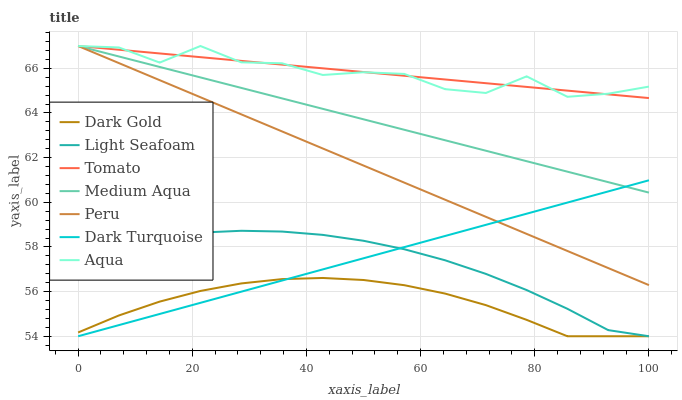Does Dark Gold have the minimum area under the curve?
Answer yes or no. Yes. Does Tomato have the maximum area under the curve?
Answer yes or no. Yes. Does Dark Turquoise have the minimum area under the curve?
Answer yes or no. No. Does Dark Turquoise have the maximum area under the curve?
Answer yes or no. No. Is Dark Turquoise the smoothest?
Answer yes or no. Yes. Is Aqua the roughest?
Answer yes or no. Yes. Is Dark Gold the smoothest?
Answer yes or no. No. Is Dark Gold the roughest?
Answer yes or no. No. Does Dark Gold have the lowest value?
Answer yes or no. Yes. Does Aqua have the lowest value?
Answer yes or no. No. Does Peru have the highest value?
Answer yes or no. Yes. Does Dark Turquoise have the highest value?
Answer yes or no. No. Is Dark Gold less than Tomato?
Answer yes or no. Yes. Is Aqua greater than Dark Turquoise?
Answer yes or no. Yes. Does Tomato intersect Aqua?
Answer yes or no. Yes. Is Tomato less than Aqua?
Answer yes or no. No. Is Tomato greater than Aqua?
Answer yes or no. No. Does Dark Gold intersect Tomato?
Answer yes or no. No. 